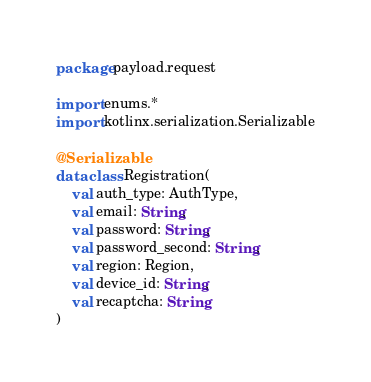Convert code to text. <code><loc_0><loc_0><loc_500><loc_500><_Kotlin_>package payload.request

import enums.*
import kotlinx.serialization.Serializable

@Serializable
data class Registration(
	val auth_type: AuthType,
	val email: String,
	val password: String,
	val password_second: String,
	val region: Region,
	val device_id: String,
	val recaptcha: String
)
</code> 